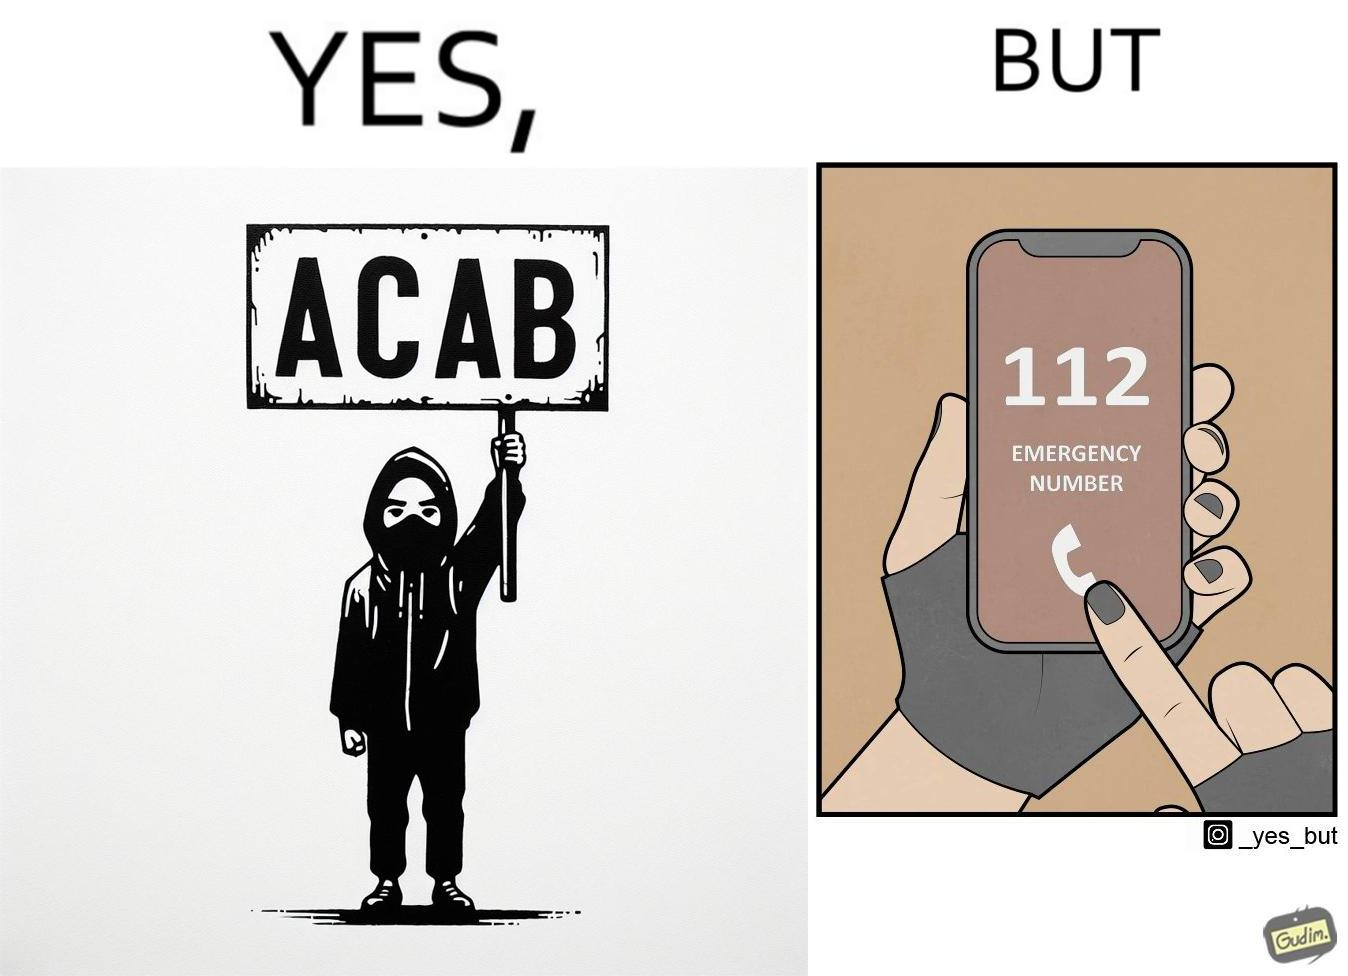Does this image contain satire or humor? Yes, this image is satirical. 